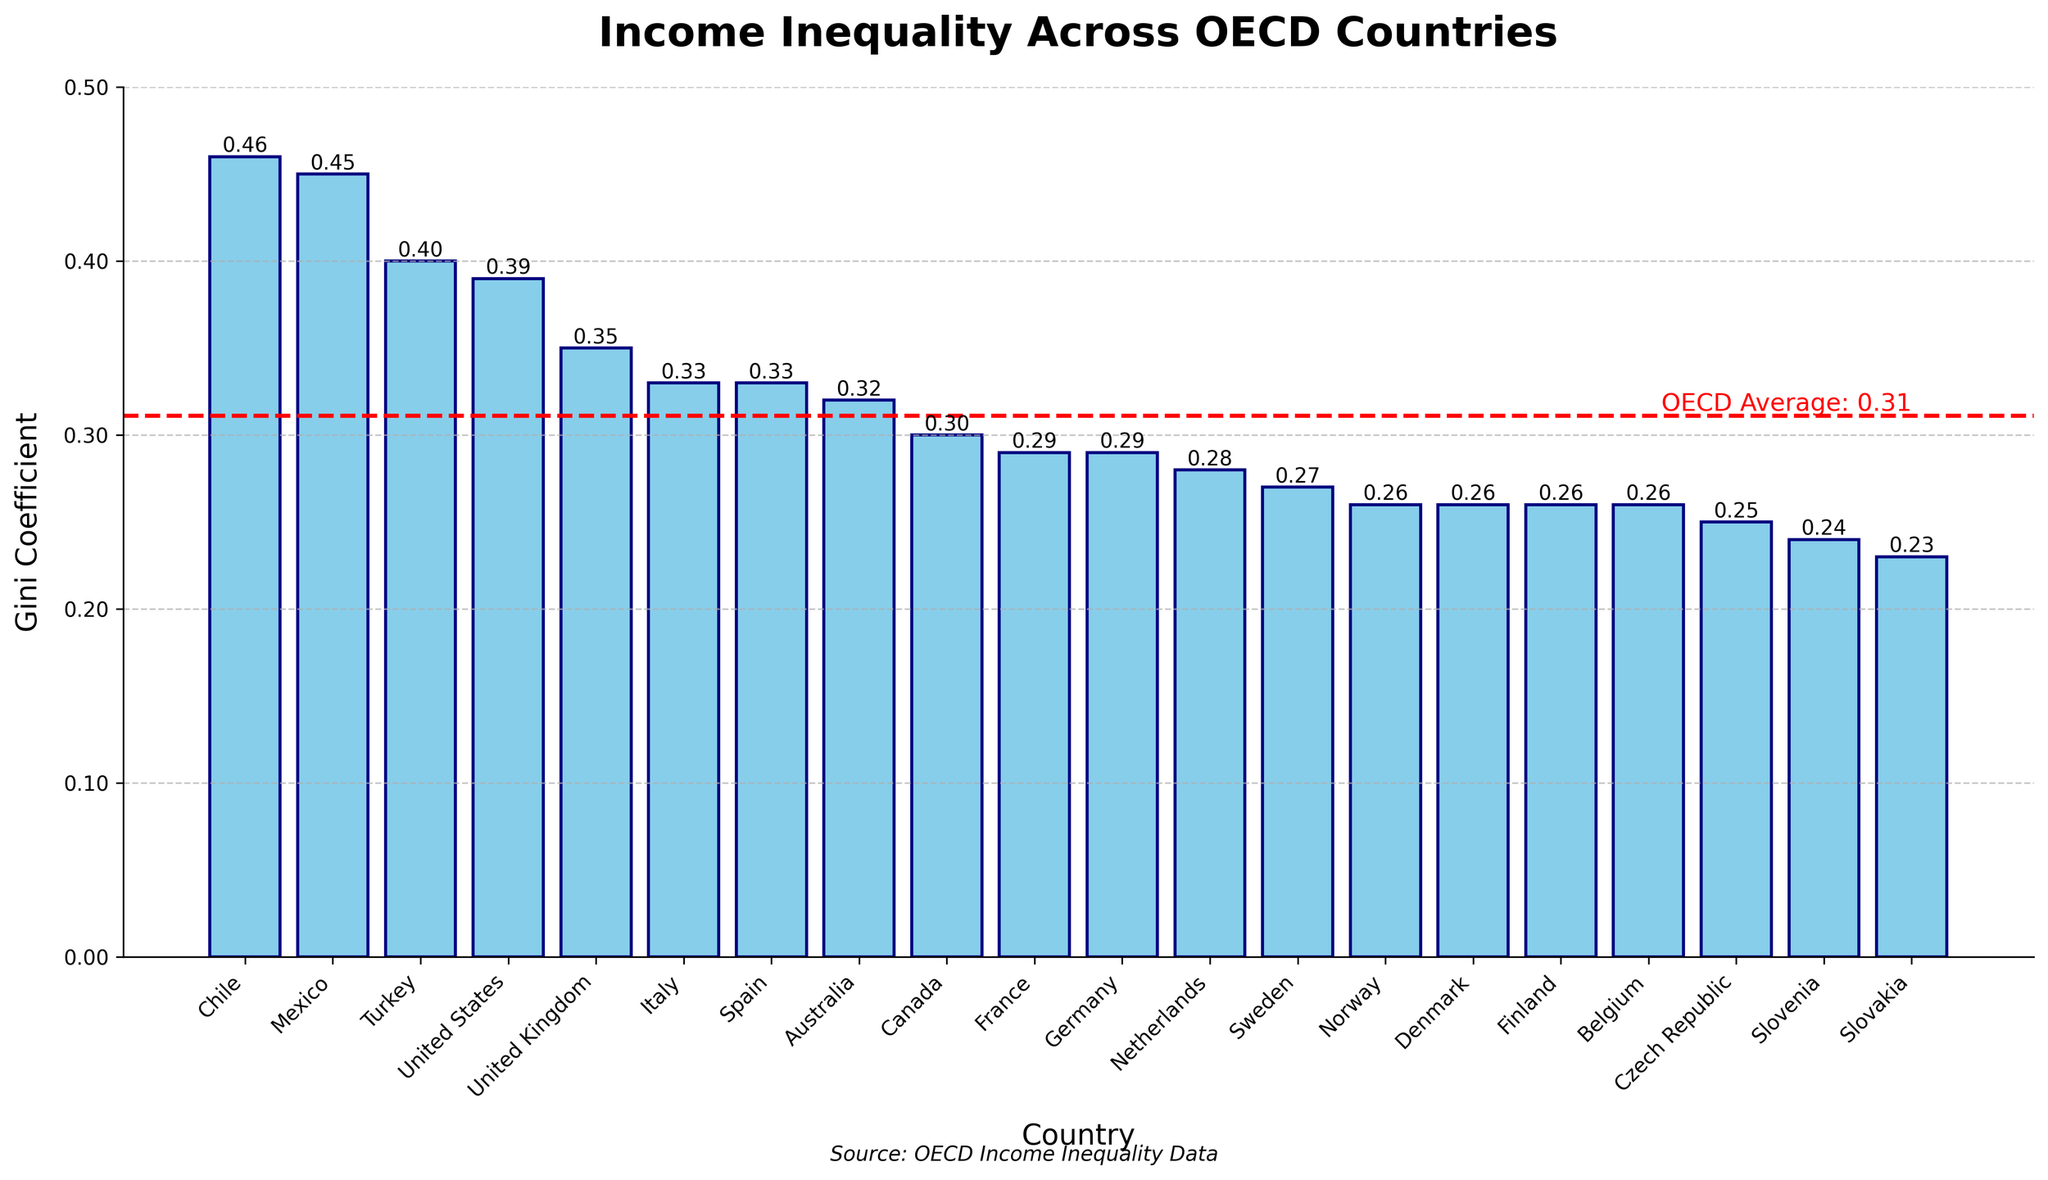Which country has the highest Gini coefficient? The country with the highest Gini coefficient has the tallest bar in the chart. In this case, it's Chile with a Gini coefficient of 0.46.
Answer: Chile What is the difference in Gini coefficients between Mexico and the Czech Republic? From the chart, Mexico has a Gini coefficient of 0.45 and the Czech Republic has a Gini coefficient of 0.25. Subtract 0.25 from 0.45.
Answer: 0.20 Which countries have a Gini coefficient below the OECD average? The OECD average Gini coefficient is indicated by a horizontal red dashed line. The countries with bars below this line are Belgium, Czech Republic, Slovenia, and Slovakia.
Answer: Belgium, Czech Republic, Slovenia, Slovakia How does the Gini coefficient of the United States compare to that of the United Kingdom? The United States has a Gini coefficient of 0.39, and the United Kingdom has a Gini coefficient of 0.35. Comparing these values, the United States has a higher Gini coefficient.
Answer: The United States has a higher Gini coefficient What is the Gini coefficient range of the top 5 most unequal countries? The top 5 countries with the highest Gini coefficients are Chile (0.46), Mexico (0.45), Turkey (0.40), the United States (0.39), and the United Kingdom (0.35). The range is the difference between the highest and lowest coefficients in this group. Subtract 0.35 from 0.46.
Answer: 0.11 